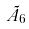Convert formula to latex. <formula><loc_0><loc_0><loc_500><loc_500>\tilde { A } _ { 6 }</formula> 